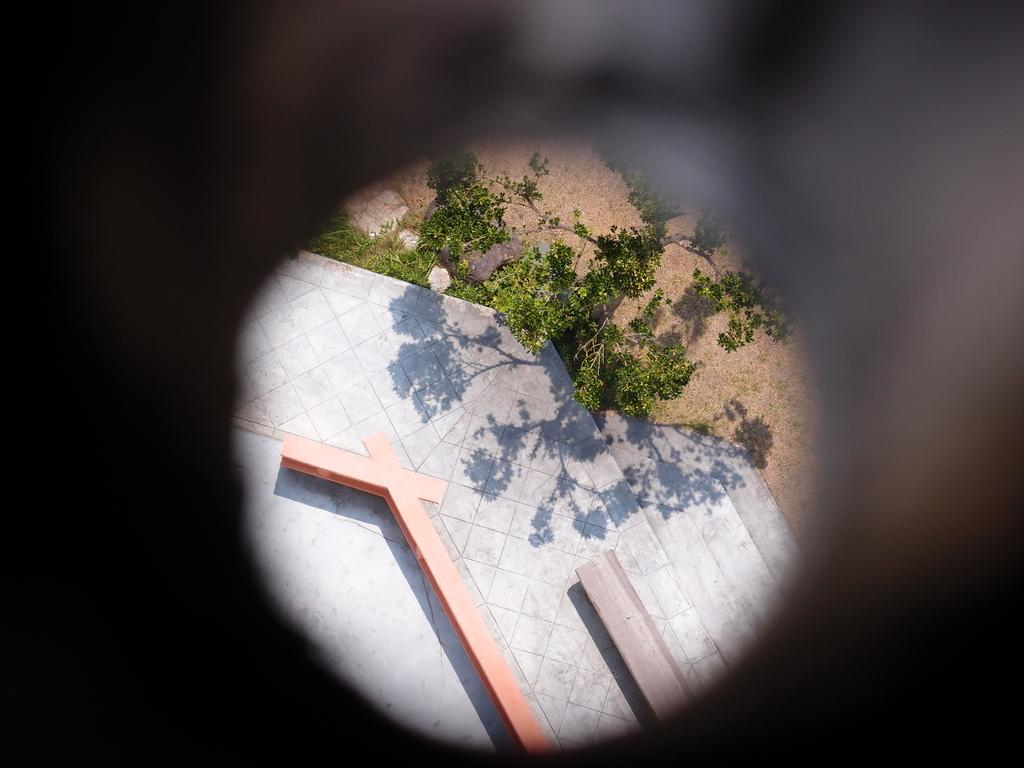What is the main feature in the center of the image? There are stairs in the center of the image. What type of plant can be seen in the image? There is a tree in the image. What type of vegetation is present in the image? There is grass in the image. What can be seen beneath the tree and grass? The ground is visible in the image. How would you describe the lighting in the image? The background of the image is dark. What type of attraction is visible in the image? There is no attraction present in the image; it features stairs, a tree, grass, and a dark background. Is there a jail visible in the image? There is no jail present in the image. 